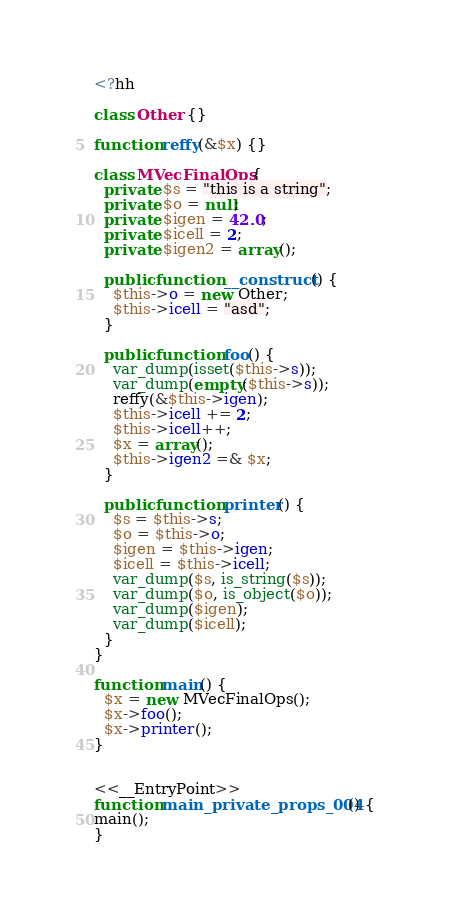Convert code to text. <code><loc_0><loc_0><loc_500><loc_500><_PHP_><?hh

class Other {}

function reffy(&$x) {}

class MVecFinalOps {
  private $s = "this is a string";
  private $o = null;
  private $igen = 42.0;
  private $icell = 2;
  private $igen2 = array();

  public function __construct() {
    $this->o = new Other;
    $this->icell = "asd";
  }

  public function foo() {
    var_dump(isset($this->s));
    var_dump(empty($this->s));
    reffy(&$this->igen);
    $this->icell += 2;
    $this->icell++;
    $x = array();
    $this->igen2 =& $x;
  }

  public function printer() {
    $s = $this->s;
    $o = $this->o;
    $igen = $this->igen;
    $icell = $this->icell;
    var_dump($s, is_string($s));
    var_dump($o, is_object($o));
    var_dump($igen);
    var_dump($icell);
  }
}

function main() {
  $x = new MVecFinalOps();
  $x->foo();
  $x->printer();
}


<<__EntryPoint>>
function main_private_props_004() {
main();
}
</code> 